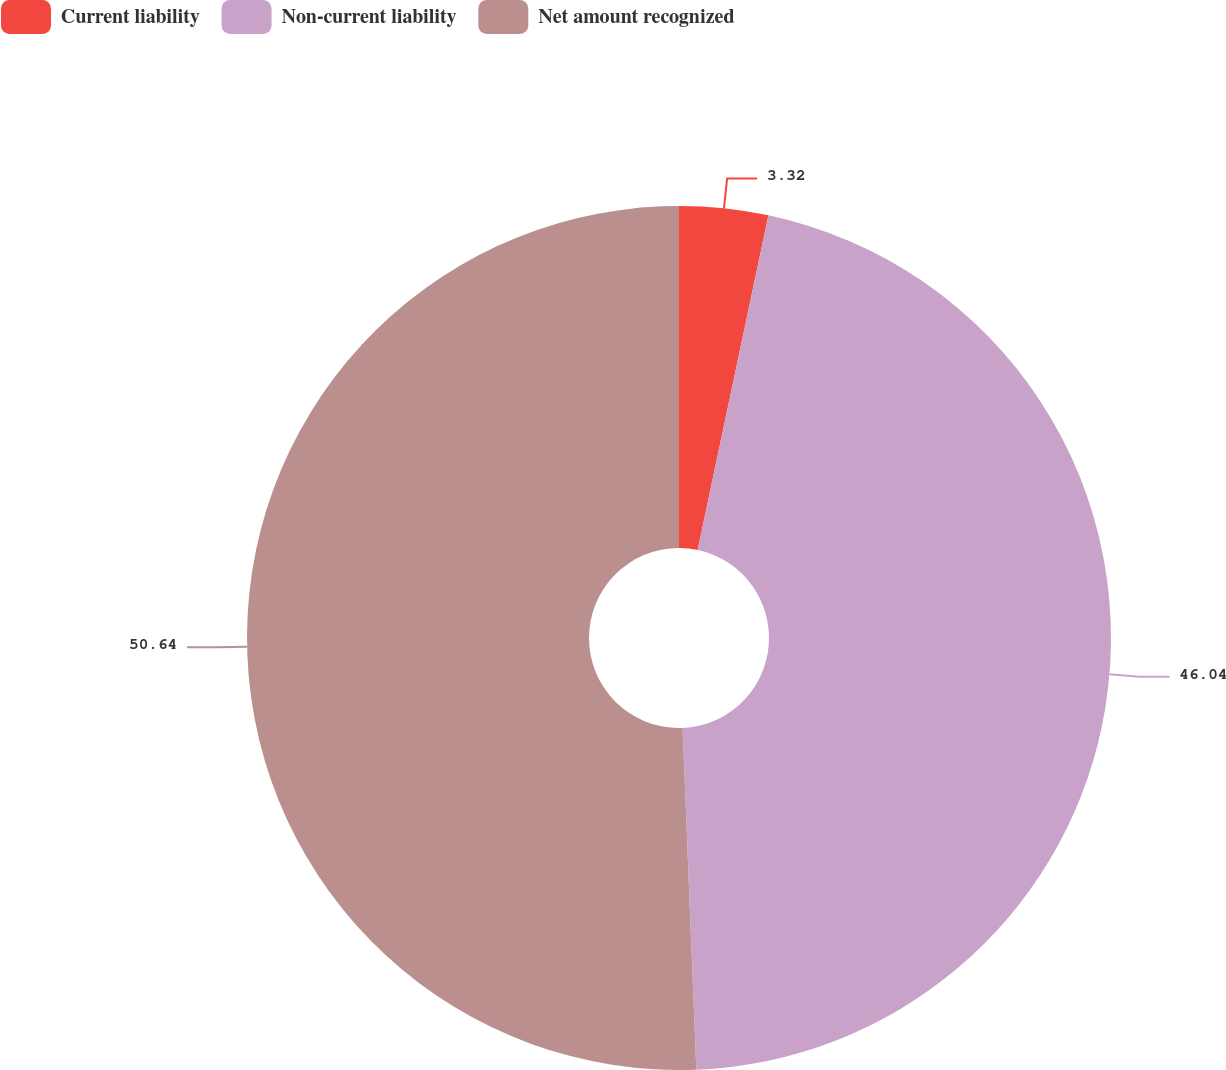Convert chart. <chart><loc_0><loc_0><loc_500><loc_500><pie_chart><fcel>Current liability<fcel>Non-current liability<fcel>Net amount recognized<nl><fcel>3.32%<fcel>46.04%<fcel>50.64%<nl></chart> 